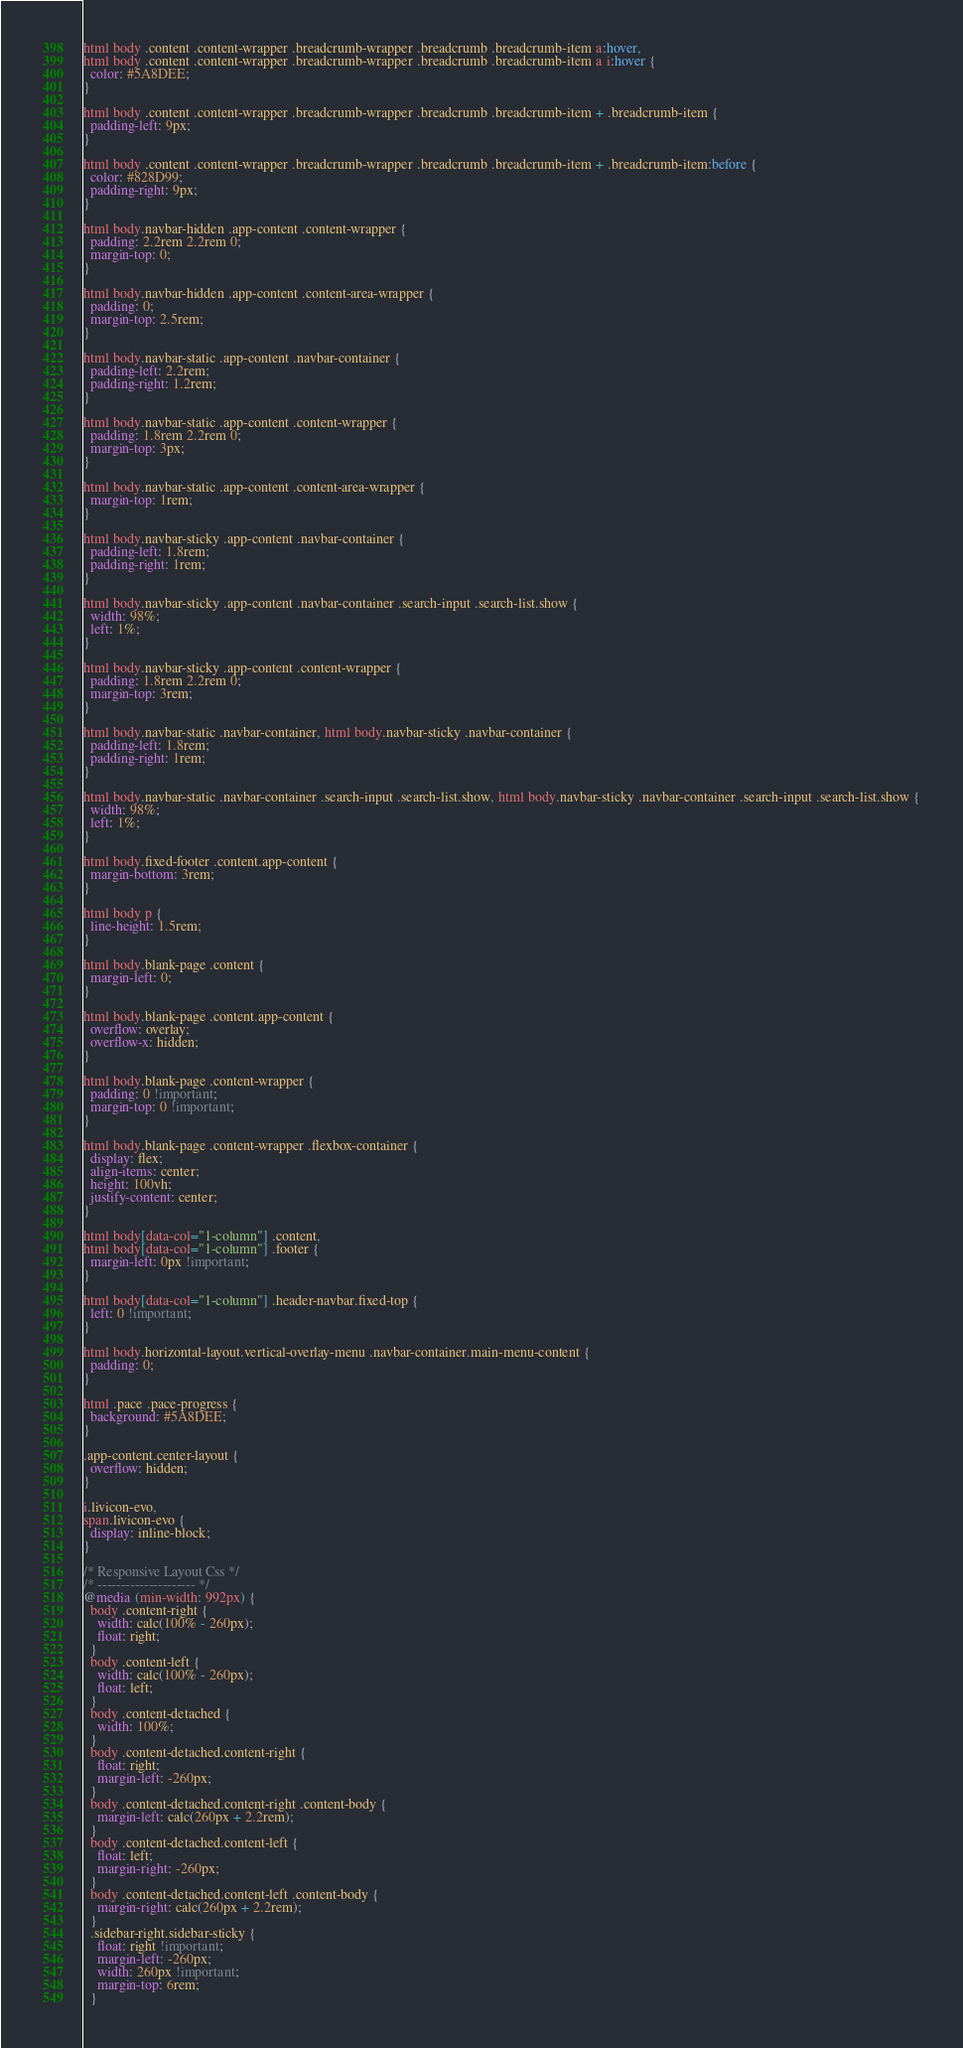Convert code to text. <code><loc_0><loc_0><loc_500><loc_500><_CSS_>
html body .content .content-wrapper .breadcrumb-wrapper .breadcrumb .breadcrumb-item a:hover,
html body .content .content-wrapper .breadcrumb-wrapper .breadcrumb .breadcrumb-item a i:hover {
  color: #5A8DEE;
}

html body .content .content-wrapper .breadcrumb-wrapper .breadcrumb .breadcrumb-item + .breadcrumb-item {
  padding-left: 9px;
}

html body .content .content-wrapper .breadcrumb-wrapper .breadcrumb .breadcrumb-item + .breadcrumb-item:before {
  color: #828D99;
  padding-right: 9px;
}

html body.navbar-hidden .app-content .content-wrapper {
  padding: 2.2rem 2.2rem 0;
  margin-top: 0;
}

html body.navbar-hidden .app-content .content-area-wrapper {
  padding: 0;
  margin-top: 2.5rem;
}

html body.navbar-static .app-content .navbar-container {
  padding-left: 2.2rem;
  padding-right: 1.2rem;
}

html body.navbar-static .app-content .content-wrapper {
  padding: 1.8rem 2.2rem 0;
  margin-top: 3px;
}

html body.navbar-static .app-content .content-area-wrapper {
  margin-top: 1rem;
}

html body.navbar-sticky .app-content .navbar-container {
  padding-left: 1.8rem;
  padding-right: 1rem;
}

html body.navbar-sticky .app-content .navbar-container .search-input .search-list.show {
  width: 98%;
  left: 1%;
}

html body.navbar-sticky .app-content .content-wrapper {
  padding: 1.8rem 2.2rem 0;
  margin-top: 3rem;
}

html body.navbar-static .navbar-container, html body.navbar-sticky .navbar-container {
  padding-left: 1.8rem;
  padding-right: 1rem;
}

html body.navbar-static .navbar-container .search-input .search-list.show, html body.navbar-sticky .navbar-container .search-input .search-list.show {
  width: 98%;
  left: 1%;
}

html body.fixed-footer .content.app-content {
  margin-bottom: 3rem;
}

html body p {
  line-height: 1.5rem;
}

html body.blank-page .content {
  margin-left: 0;
}

html body.blank-page .content.app-content {
  overflow: overlay;
  overflow-x: hidden;
}

html body.blank-page .content-wrapper {
  padding: 0 !important;
  margin-top: 0 !important;
}

html body.blank-page .content-wrapper .flexbox-container {
  display: flex;
  align-items: center;
  height: 100vh;
  justify-content: center;
}

html body[data-col="1-column"] .content,
html body[data-col="1-column"] .footer {
  margin-left: 0px !important;
}

html body[data-col="1-column"] .header-navbar.fixed-top {
  left: 0 !important;
}

html body.horizontal-layout.vertical-overlay-menu .navbar-container.main-menu-content {
  padding: 0;
}

html .pace .pace-progress {
  background: #5A8DEE;
}

.app-content.center-layout {
  overflow: hidden;
}

i.livicon-evo,
span.livicon-evo {
  display: inline-block;
}

/* Responsive Layout Css */
/* --------------------- */
@media (min-width: 992px) {
  body .content-right {
    width: calc(100% - 260px);
    float: right;
  }
  body .content-left {
    width: calc(100% - 260px);
    float: left;
  }
  body .content-detached {
    width: 100%;
  }
  body .content-detached.content-right {
    float: right;
    margin-left: -260px;
  }
  body .content-detached.content-right .content-body {
    margin-left: calc(260px + 2.2rem);
  }
  body .content-detached.content-left {
    float: left;
    margin-right: -260px;
  }
  body .content-detached.content-left .content-body {
    margin-right: calc(260px + 2.2rem);
  }
  .sidebar-right.sidebar-sticky {
    float: right !important;
    margin-left: -260px;
    width: 260px !important;
    margin-top: 6rem;
  }</code> 